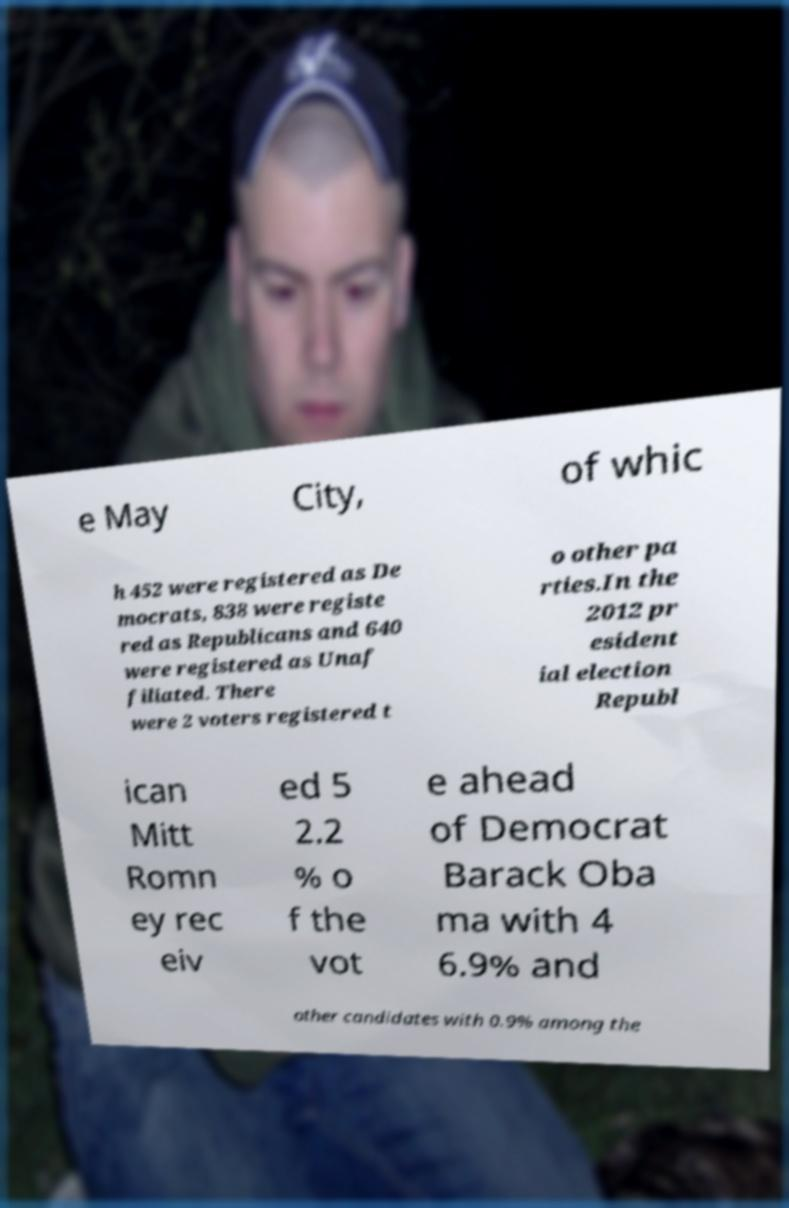Please identify and transcribe the text found in this image. e May City, of whic h 452 were registered as De mocrats, 838 were registe red as Republicans and 640 were registered as Unaf filiated. There were 2 voters registered t o other pa rties.In the 2012 pr esident ial election Republ ican Mitt Romn ey rec eiv ed 5 2.2 % o f the vot e ahead of Democrat Barack Oba ma with 4 6.9% and other candidates with 0.9% among the 